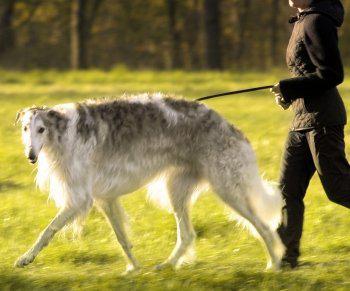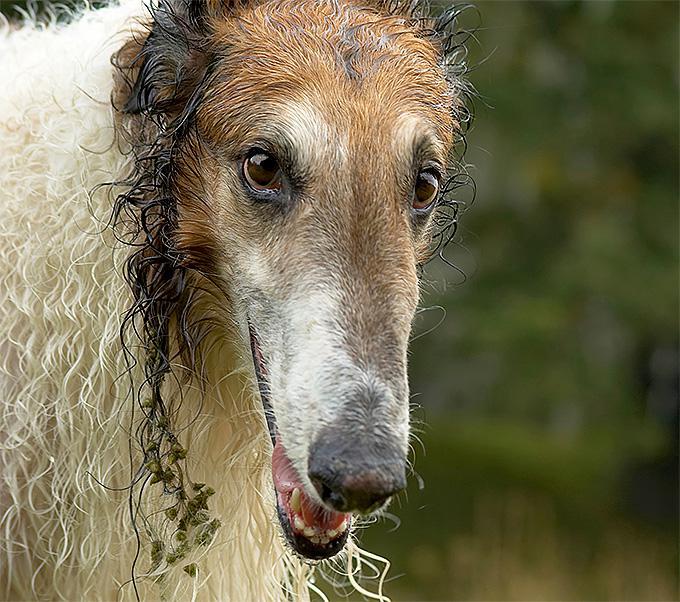The first image is the image on the left, the second image is the image on the right. For the images shown, is this caption "The dog on the right is white with black spots." true? Answer yes or no. No. The first image is the image on the left, the second image is the image on the right. Evaluate the accuracy of this statement regarding the images: "An image shows a hound standing on the grassy ground.". Is it true? Answer yes or no. Yes. 